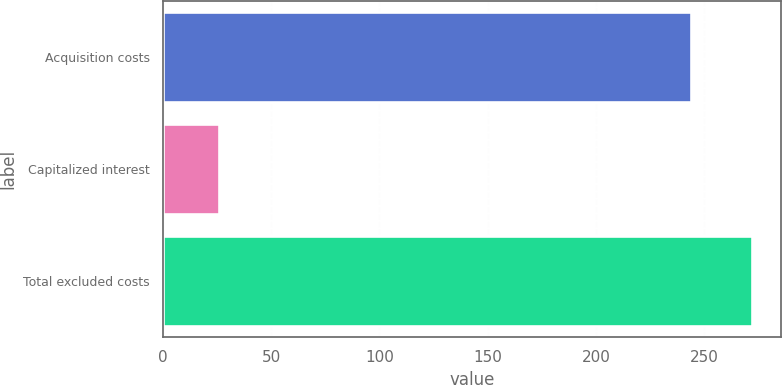<chart> <loc_0><loc_0><loc_500><loc_500><bar_chart><fcel>Acquisition costs<fcel>Capitalized interest<fcel>Total excluded costs<nl><fcel>244<fcel>26<fcel>272<nl></chart> 